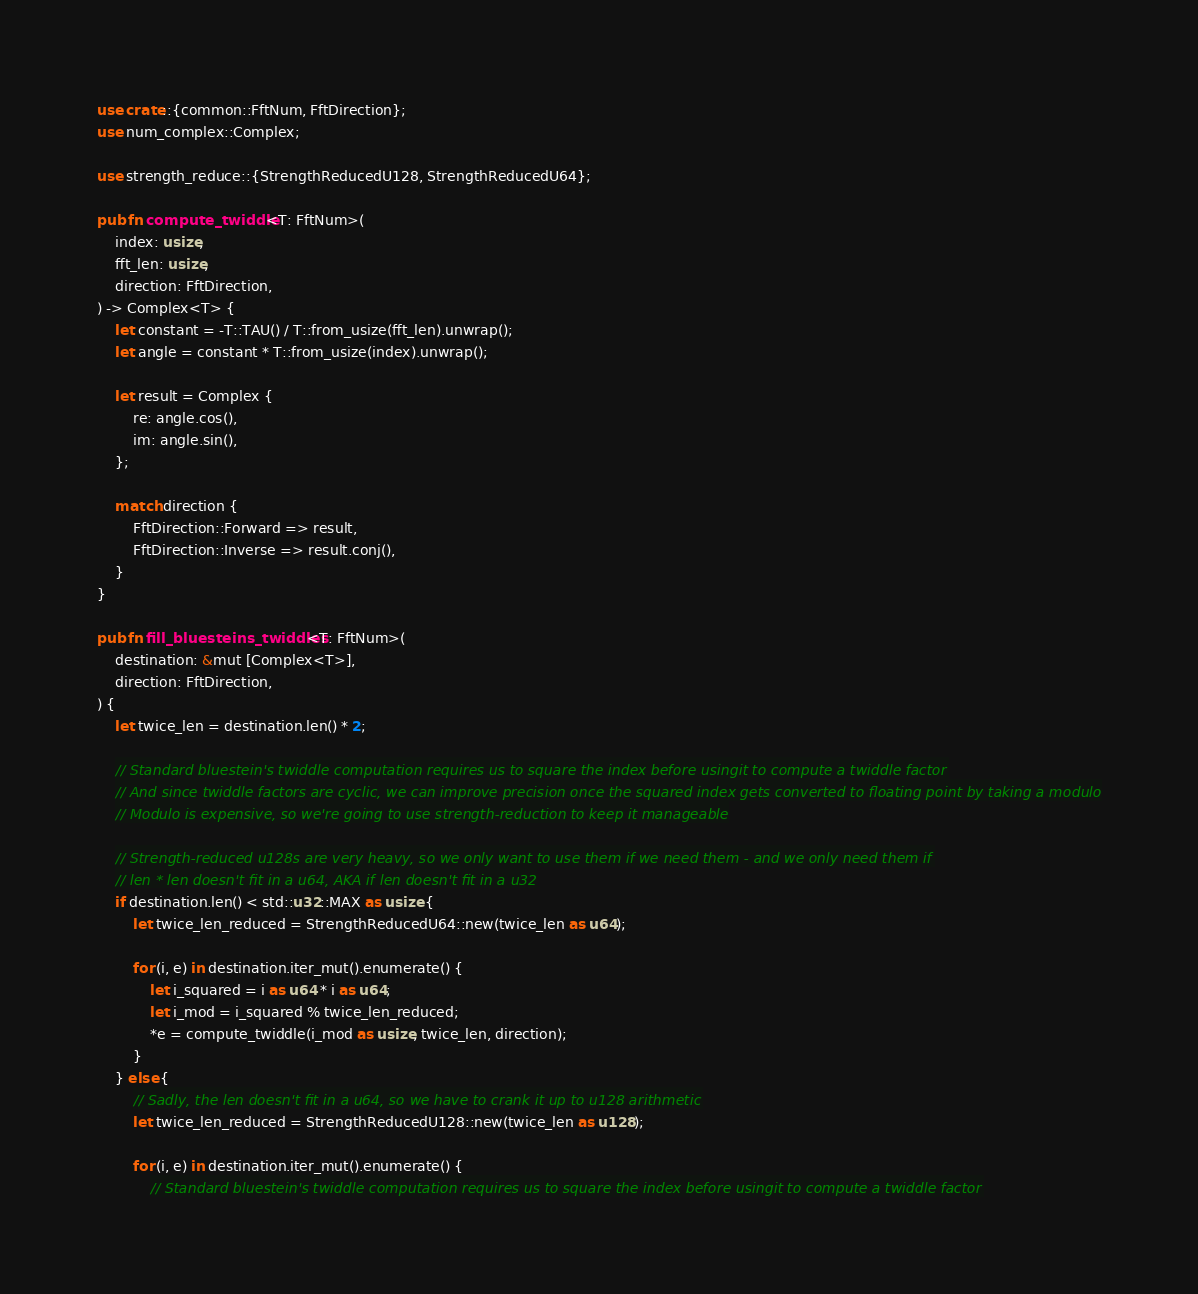Convert code to text. <code><loc_0><loc_0><loc_500><loc_500><_Rust_>use crate::{common::FftNum, FftDirection};
use num_complex::Complex;

use strength_reduce::{StrengthReducedU128, StrengthReducedU64};

pub fn compute_twiddle<T: FftNum>(
    index: usize,
    fft_len: usize,
    direction: FftDirection,
) -> Complex<T> {
    let constant = -T::TAU() / T::from_usize(fft_len).unwrap();
    let angle = constant * T::from_usize(index).unwrap();

    let result = Complex {
        re: angle.cos(),
        im: angle.sin(),
    };

    match direction {
        FftDirection::Forward => result,
        FftDirection::Inverse => result.conj(),
    }
}

pub fn fill_bluesteins_twiddles<T: FftNum>(
    destination: &mut [Complex<T>],
    direction: FftDirection,
) {
    let twice_len = destination.len() * 2;

    // Standard bluestein's twiddle computation requires us to square the index before usingit to compute a twiddle factor
    // And since twiddle factors are cyclic, we can improve precision once the squared index gets converted to floating point by taking a modulo
    // Modulo is expensive, so we're going to use strength-reduction to keep it manageable

    // Strength-reduced u128s are very heavy, so we only want to use them if we need them - and we only need them if
    // len * len doesn't fit in a u64, AKA if len doesn't fit in a u32
    if destination.len() < std::u32::MAX as usize {
        let twice_len_reduced = StrengthReducedU64::new(twice_len as u64);

        for (i, e) in destination.iter_mut().enumerate() {
            let i_squared = i as u64 * i as u64;
            let i_mod = i_squared % twice_len_reduced;
            *e = compute_twiddle(i_mod as usize, twice_len, direction);
        }
    } else {
        // Sadly, the len doesn't fit in a u64, so we have to crank it up to u128 arithmetic
        let twice_len_reduced = StrengthReducedU128::new(twice_len as u128);

        for (i, e) in destination.iter_mut().enumerate() {
            // Standard bluestein's twiddle computation requires us to square the index before usingit to compute a twiddle factor</code> 